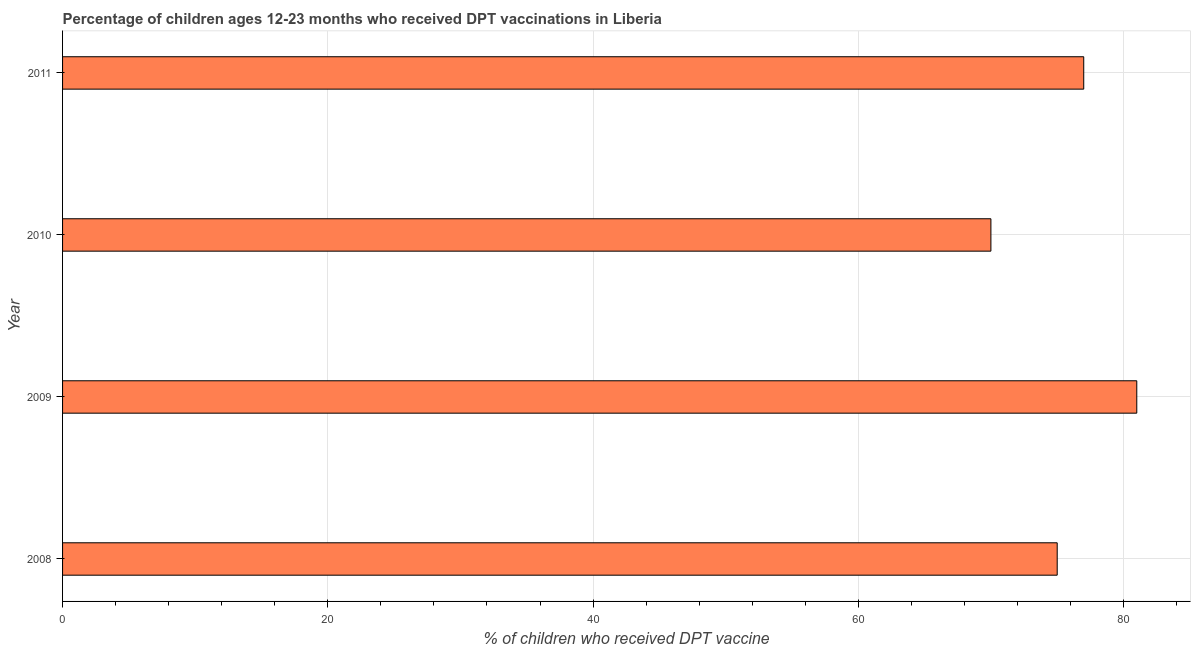Does the graph contain any zero values?
Provide a succinct answer. No. What is the title of the graph?
Keep it short and to the point. Percentage of children ages 12-23 months who received DPT vaccinations in Liberia. What is the label or title of the X-axis?
Your answer should be very brief. % of children who received DPT vaccine. What is the percentage of children who received dpt vaccine in 2010?
Offer a very short reply. 70. Across all years, what is the maximum percentage of children who received dpt vaccine?
Offer a terse response. 81. Across all years, what is the minimum percentage of children who received dpt vaccine?
Keep it short and to the point. 70. In which year was the percentage of children who received dpt vaccine maximum?
Make the answer very short. 2009. In which year was the percentage of children who received dpt vaccine minimum?
Your response must be concise. 2010. What is the sum of the percentage of children who received dpt vaccine?
Your answer should be compact. 303. What is the difference between the percentage of children who received dpt vaccine in 2010 and 2011?
Your answer should be compact. -7. What is the median percentage of children who received dpt vaccine?
Make the answer very short. 76. Is the sum of the percentage of children who received dpt vaccine in 2008 and 2011 greater than the maximum percentage of children who received dpt vaccine across all years?
Ensure brevity in your answer.  Yes. What is the difference between the highest and the lowest percentage of children who received dpt vaccine?
Give a very brief answer. 11. In how many years, is the percentage of children who received dpt vaccine greater than the average percentage of children who received dpt vaccine taken over all years?
Your response must be concise. 2. Are all the bars in the graph horizontal?
Your response must be concise. Yes. What is the difference between two consecutive major ticks on the X-axis?
Your answer should be compact. 20. Are the values on the major ticks of X-axis written in scientific E-notation?
Offer a very short reply. No. What is the % of children who received DPT vaccine of 2009?
Offer a terse response. 81. What is the difference between the % of children who received DPT vaccine in 2009 and 2011?
Provide a short and direct response. 4. What is the difference between the % of children who received DPT vaccine in 2010 and 2011?
Offer a terse response. -7. What is the ratio of the % of children who received DPT vaccine in 2008 to that in 2009?
Your answer should be very brief. 0.93. What is the ratio of the % of children who received DPT vaccine in 2008 to that in 2010?
Provide a succinct answer. 1.07. What is the ratio of the % of children who received DPT vaccine in 2009 to that in 2010?
Ensure brevity in your answer.  1.16. What is the ratio of the % of children who received DPT vaccine in 2009 to that in 2011?
Offer a terse response. 1.05. What is the ratio of the % of children who received DPT vaccine in 2010 to that in 2011?
Make the answer very short. 0.91. 